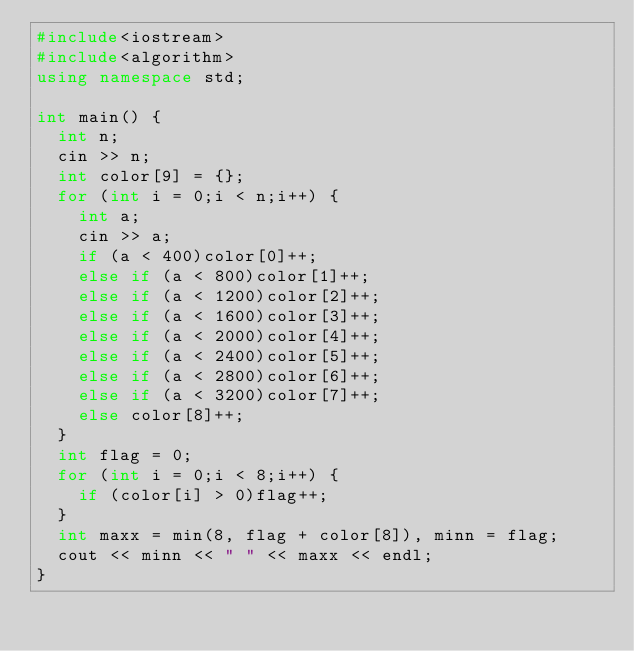Convert code to text. <code><loc_0><loc_0><loc_500><loc_500><_C++_>#include<iostream>
#include<algorithm>
using namespace std;

int main() {
	int n;
	cin >> n;
	int color[9] = {};
	for (int i = 0;i < n;i++) {
		int a;
		cin >> a;
		if (a < 400)color[0]++;
		else if (a < 800)color[1]++;
		else if (a < 1200)color[2]++;
		else if (a < 1600)color[3]++;
		else if (a < 2000)color[4]++;
		else if (a < 2400)color[5]++;
		else if (a < 2800)color[6]++;
		else if (a < 3200)color[7]++;
		else color[8]++;
	}
	int flag = 0;
	for (int i = 0;i < 8;i++) {
		if (color[i] > 0)flag++;
	}
	int maxx = min(8, flag + color[8]), minn = flag;
	cout << minn << " " << maxx << endl;
}</code> 